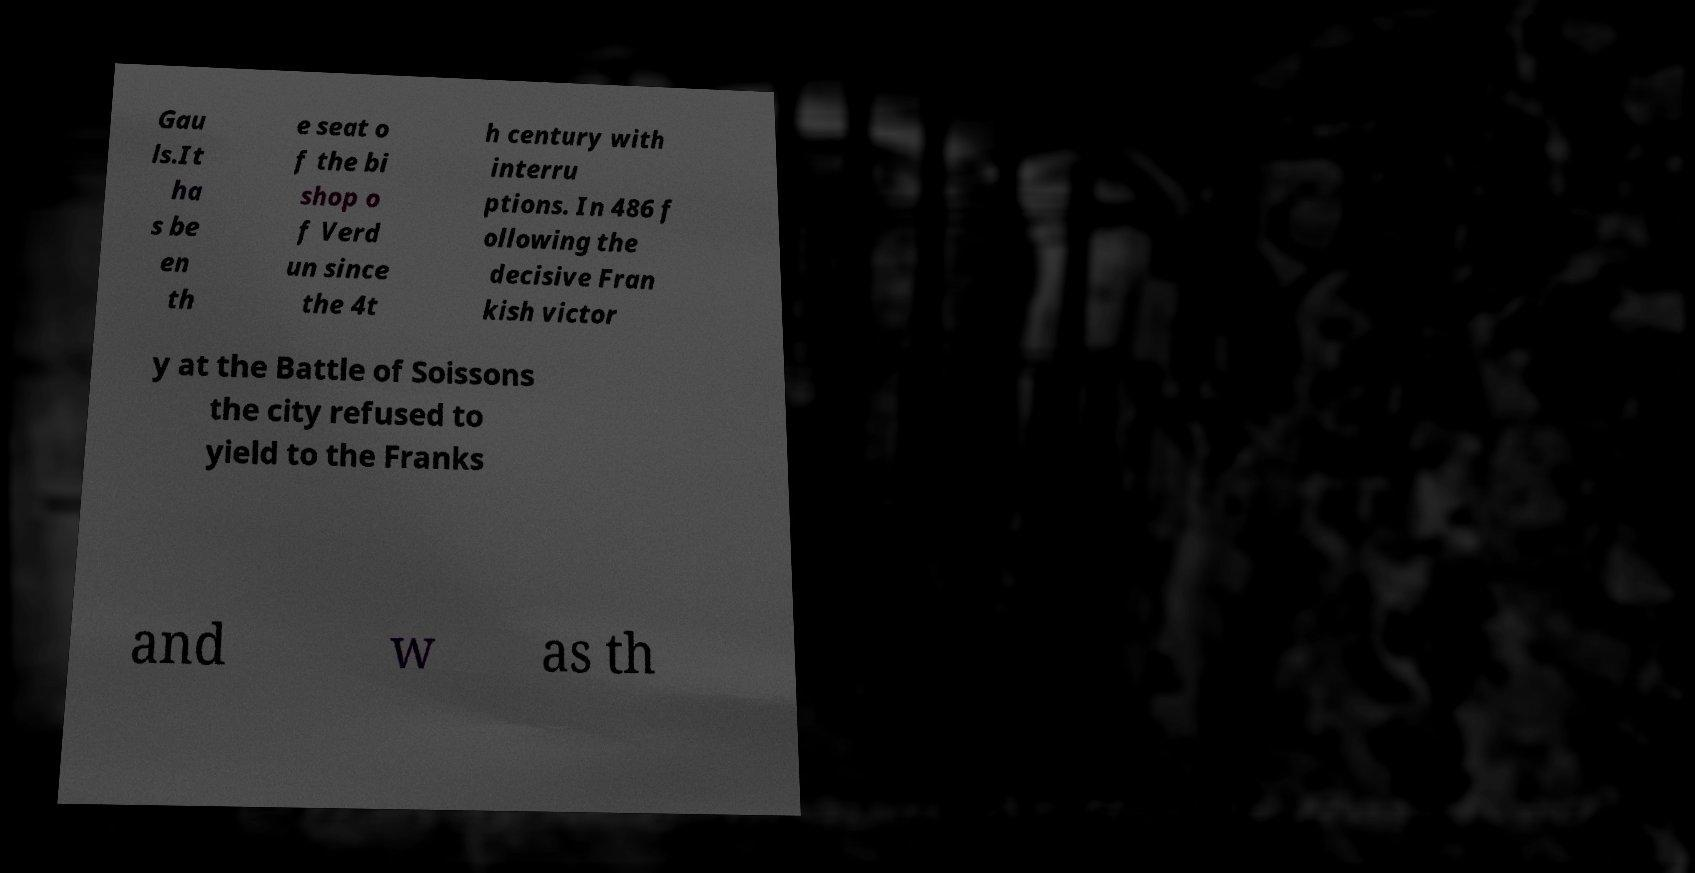Please read and relay the text visible in this image. What does it say? Gau ls.It ha s be en th e seat o f the bi shop o f Verd un since the 4t h century with interru ptions. In 486 f ollowing the decisive Fran kish victor y at the Battle of Soissons the city refused to yield to the Franks and w as th 